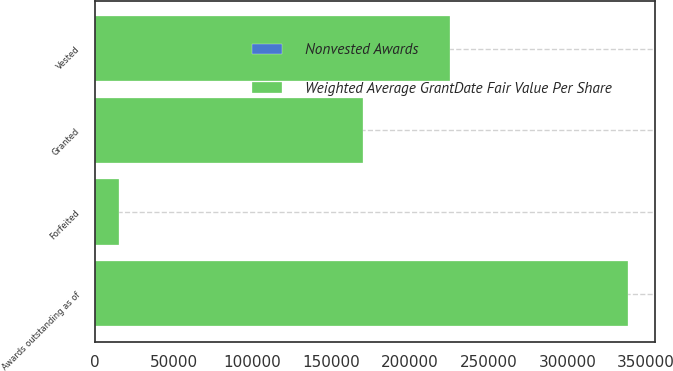Convert chart to OTSL. <chart><loc_0><loc_0><loc_500><loc_500><stacked_bar_chart><ecel><fcel>Awards outstanding as of<fcel>Granted<fcel>Vested<fcel>Forfeited<nl><fcel>Weighted Average GrantDate Fair Value Per Share<fcel>338389<fcel>170327<fcel>225126<fcel>15237<nl><fcel>Nonvested Awards<fcel>88.75<fcel>88.79<fcel>47.71<fcel>91.88<nl></chart> 